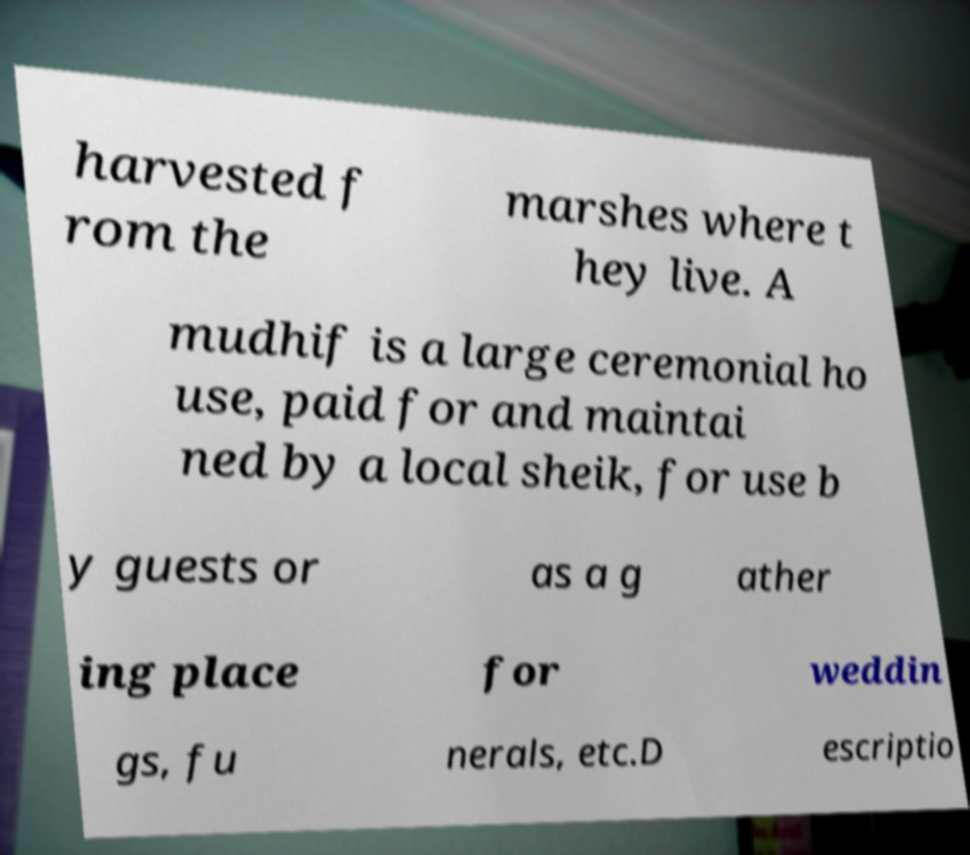Please read and relay the text visible in this image. What does it say? harvested f rom the marshes where t hey live. A mudhif is a large ceremonial ho use, paid for and maintai ned by a local sheik, for use b y guests or as a g ather ing place for weddin gs, fu nerals, etc.D escriptio 